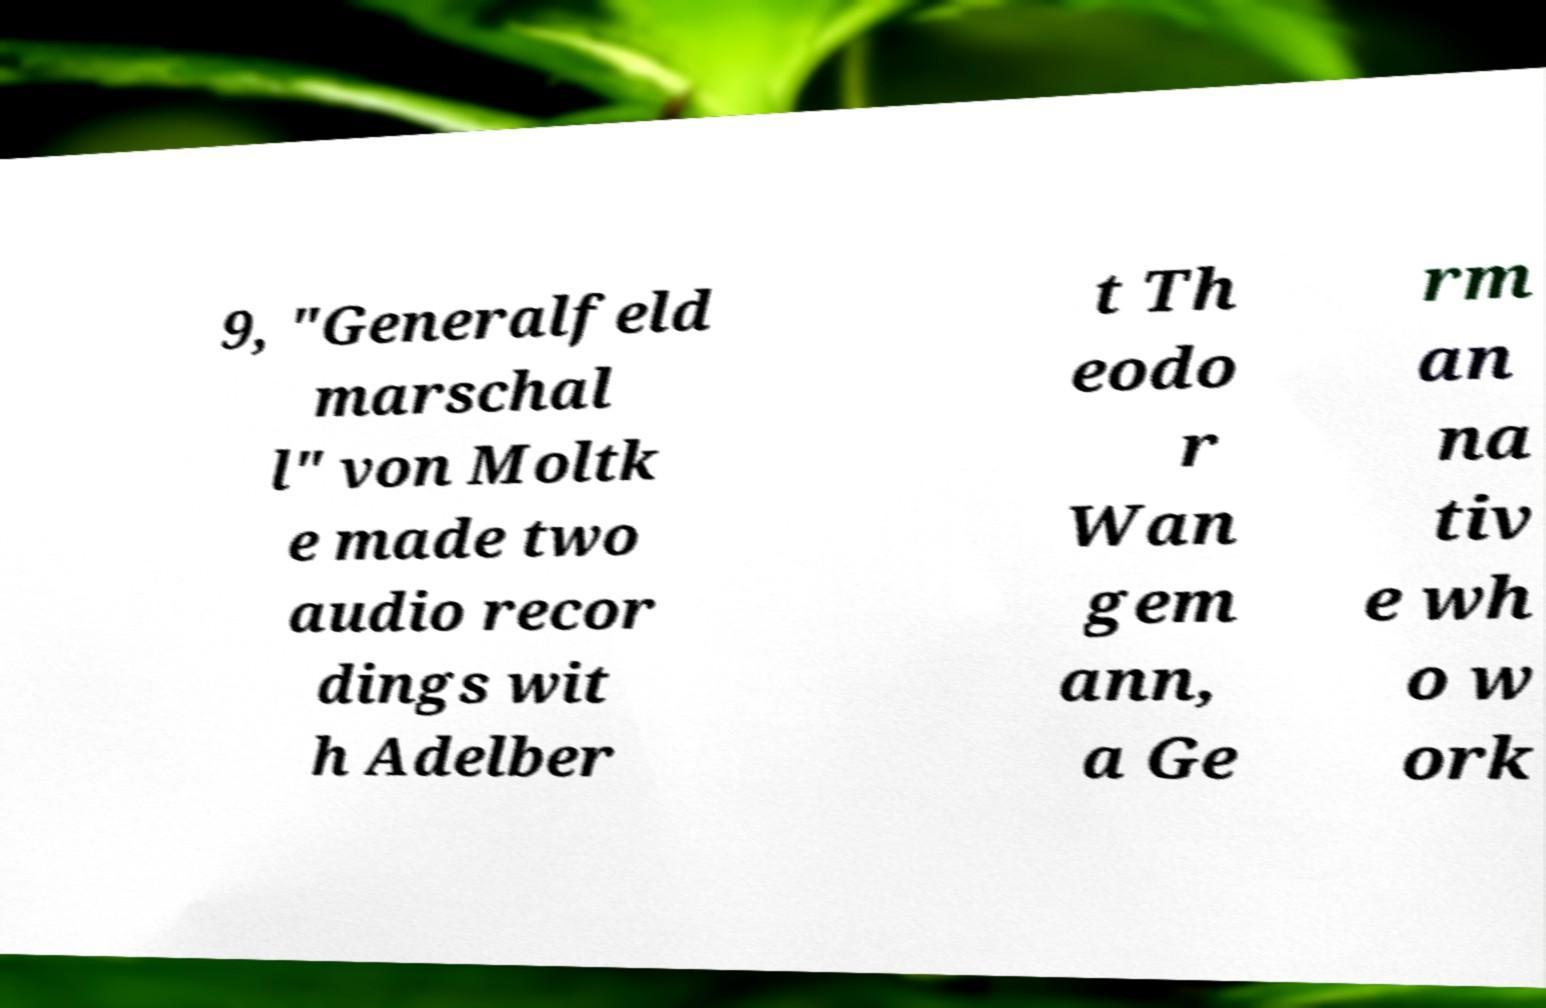Please read and relay the text visible in this image. What does it say? 9, "Generalfeld marschal l" von Moltk e made two audio recor dings wit h Adelber t Th eodo r Wan gem ann, a Ge rm an na tiv e wh o w ork 